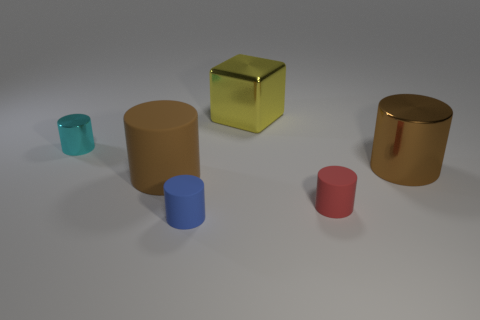What is the size of the brown object left of the tiny thing to the right of the blue matte object?
Ensure brevity in your answer.  Large. Do the blue matte cylinder and the cyan metal cylinder have the same size?
Your answer should be compact. Yes. There is a blue object that is in front of the large brown thing to the left of the small blue thing; are there any large brown things that are left of it?
Keep it short and to the point. Yes. The cyan metallic cylinder is what size?
Make the answer very short. Small. What number of cyan metallic things are the same size as the blue thing?
Keep it short and to the point. 1. What is the material of the other brown thing that is the same shape as the large matte object?
Your answer should be compact. Metal. There is a small object that is both behind the small blue cylinder and to the right of the cyan cylinder; what is its shape?
Ensure brevity in your answer.  Cylinder. There is a shiny thing that is on the left side of the large yellow block; what shape is it?
Provide a short and direct response. Cylinder. What number of cylinders are in front of the small shiny cylinder and left of the blue rubber cylinder?
Offer a very short reply. 1. There is a block; does it have the same size as the brown object to the right of the small blue object?
Offer a very short reply. Yes. 